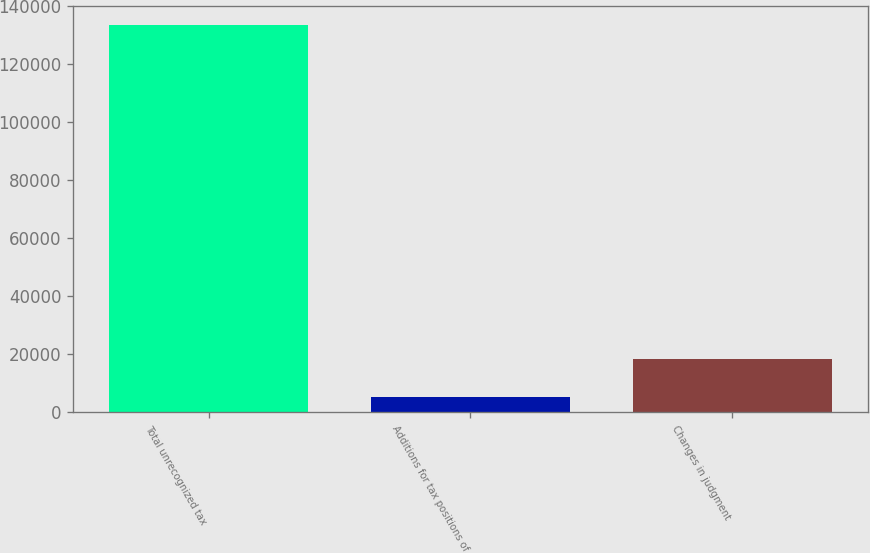<chart> <loc_0><loc_0><loc_500><loc_500><bar_chart><fcel>Total unrecognized tax<fcel>Additions for tax positions of<fcel>Changes in judgment<nl><fcel>133422<fcel>5167<fcel>18250.8<nl></chart> 